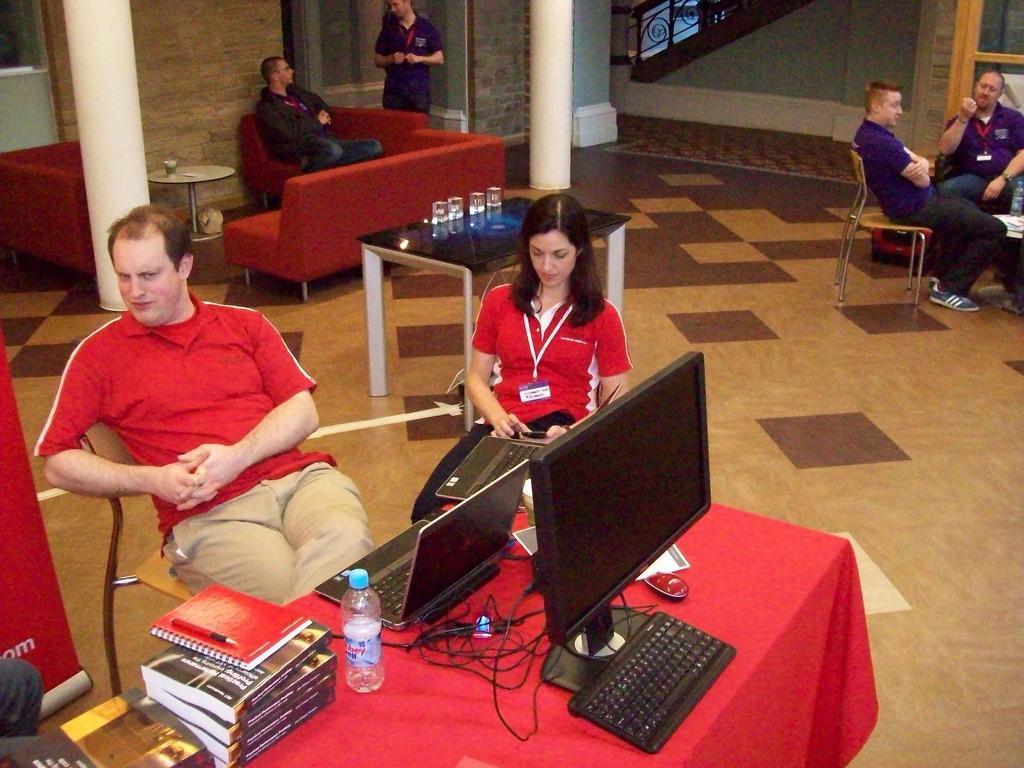What are the people in the image doing? The people in the image are sitting on chairs. What type of furniture is visible in the image? There is a desktop in the image. What electronic devices can be seen in the image? There are laptops in the image. What type of disposable containers are present in the image? Disposable bottles are present in the image. What type of office supplies or stationary items can be seen in the image? Some stationary items are visible in the image. What type of pigs are being offered to the people in the image? There are no pigs present in the image; it features people sitting on chairs, a desktop, laptops, disposable bottles, and stationary items. What is the plot of the story being told in the image? The image does not depict a story or plot; it is a static scene of people sitting in a room with various objects. 